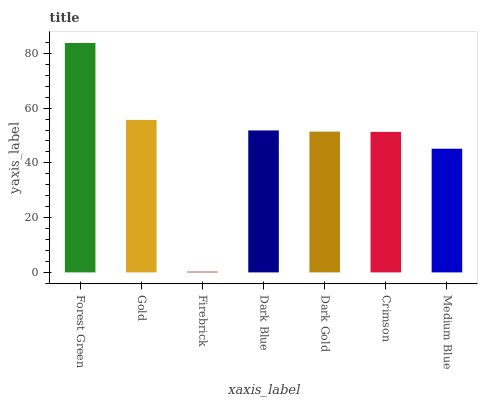Is Firebrick the minimum?
Answer yes or no. Yes. Is Forest Green the maximum?
Answer yes or no. Yes. Is Gold the minimum?
Answer yes or no. No. Is Gold the maximum?
Answer yes or no. No. Is Forest Green greater than Gold?
Answer yes or no. Yes. Is Gold less than Forest Green?
Answer yes or no. Yes. Is Gold greater than Forest Green?
Answer yes or no. No. Is Forest Green less than Gold?
Answer yes or no. No. Is Dark Gold the high median?
Answer yes or no. Yes. Is Dark Gold the low median?
Answer yes or no. Yes. Is Gold the high median?
Answer yes or no. No. Is Firebrick the low median?
Answer yes or no. No. 